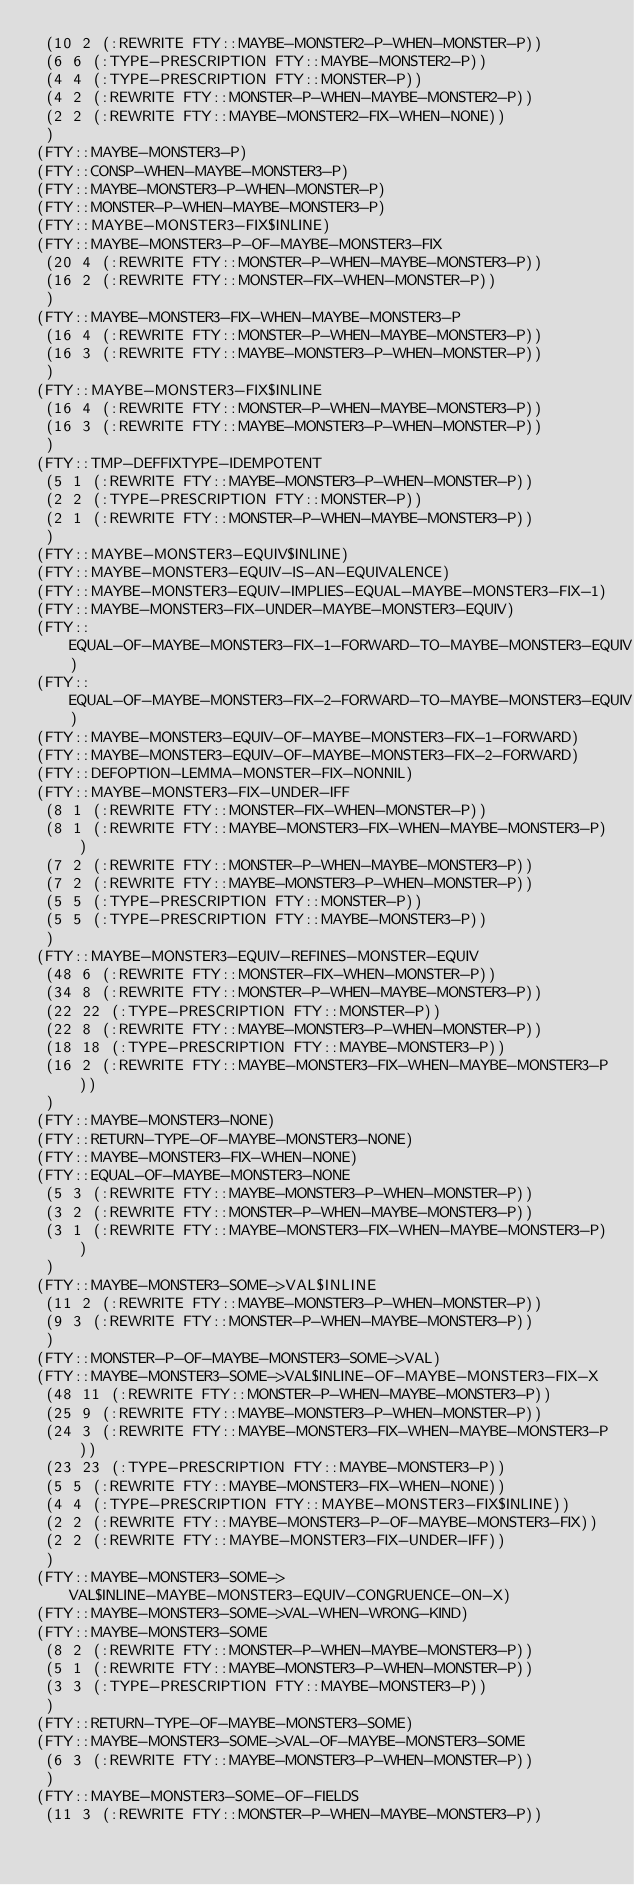<code> <loc_0><loc_0><loc_500><loc_500><_Lisp_> (10 2 (:REWRITE FTY::MAYBE-MONSTER2-P-WHEN-MONSTER-P))
 (6 6 (:TYPE-PRESCRIPTION FTY::MAYBE-MONSTER2-P))
 (4 4 (:TYPE-PRESCRIPTION FTY::MONSTER-P))
 (4 2 (:REWRITE FTY::MONSTER-P-WHEN-MAYBE-MONSTER2-P))
 (2 2 (:REWRITE FTY::MAYBE-MONSTER2-FIX-WHEN-NONE))
 )
(FTY::MAYBE-MONSTER3-P)
(FTY::CONSP-WHEN-MAYBE-MONSTER3-P)
(FTY::MAYBE-MONSTER3-P-WHEN-MONSTER-P)
(FTY::MONSTER-P-WHEN-MAYBE-MONSTER3-P)
(FTY::MAYBE-MONSTER3-FIX$INLINE)
(FTY::MAYBE-MONSTER3-P-OF-MAYBE-MONSTER3-FIX
 (20 4 (:REWRITE FTY::MONSTER-P-WHEN-MAYBE-MONSTER3-P))
 (16 2 (:REWRITE FTY::MONSTER-FIX-WHEN-MONSTER-P))
 )
(FTY::MAYBE-MONSTER3-FIX-WHEN-MAYBE-MONSTER3-P
 (16 4 (:REWRITE FTY::MONSTER-P-WHEN-MAYBE-MONSTER3-P))
 (16 3 (:REWRITE FTY::MAYBE-MONSTER3-P-WHEN-MONSTER-P))
 )
(FTY::MAYBE-MONSTER3-FIX$INLINE
 (16 4 (:REWRITE FTY::MONSTER-P-WHEN-MAYBE-MONSTER3-P))
 (16 3 (:REWRITE FTY::MAYBE-MONSTER3-P-WHEN-MONSTER-P))
 )
(FTY::TMP-DEFFIXTYPE-IDEMPOTENT
 (5 1 (:REWRITE FTY::MAYBE-MONSTER3-P-WHEN-MONSTER-P))
 (2 2 (:TYPE-PRESCRIPTION FTY::MONSTER-P))
 (2 1 (:REWRITE FTY::MONSTER-P-WHEN-MAYBE-MONSTER3-P))
 )
(FTY::MAYBE-MONSTER3-EQUIV$INLINE)
(FTY::MAYBE-MONSTER3-EQUIV-IS-AN-EQUIVALENCE)
(FTY::MAYBE-MONSTER3-EQUIV-IMPLIES-EQUAL-MAYBE-MONSTER3-FIX-1)
(FTY::MAYBE-MONSTER3-FIX-UNDER-MAYBE-MONSTER3-EQUIV)
(FTY::EQUAL-OF-MAYBE-MONSTER3-FIX-1-FORWARD-TO-MAYBE-MONSTER3-EQUIV)
(FTY::EQUAL-OF-MAYBE-MONSTER3-FIX-2-FORWARD-TO-MAYBE-MONSTER3-EQUIV)
(FTY::MAYBE-MONSTER3-EQUIV-OF-MAYBE-MONSTER3-FIX-1-FORWARD)
(FTY::MAYBE-MONSTER3-EQUIV-OF-MAYBE-MONSTER3-FIX-2-FORWARD)
(FTY::DEFOPTION-LEMMA-MONSTER-FIX-NONNIL)
(FTY::MAYBE-MONSTER3-FIX-UNDER-IFF
 (8 1 (:REWRITE FTY::MONSTER-FIX-WHEN-MONSTER-P))
 (8 1 (:REWRITE FTY::MAYBE-MONSTER3-FIX-WHEN-MAYBE-MONSTER3-P))
 (7 2 (:REWRITE FTY::MONSTER-P-WHEN-MAYBE-MONSTER3-P))
 (7 2 (:REWRITE FTY::MAYBE-MONSTER3-P-WHEN-MONSTER-P))
 (5 5 (:TYPE-PRESCRIPTION FTY::MONSTER-P))
 (5 5 (:TYPE-PRESCRIPTION FTY::MAYBE-MONSTER3-P))
 )
(FTY::MAYBE-MONSTER3-EQUIV-REFINES-MONSTER-EQUIV
 (48 6 (:REWRITE FTY::MONSTER-FIX-WHEN-MONSTER-P))
 (34 8 (:REWRITE FTY::MONSTER-P-WHEN-MAYBE-MONSTER3-P))
 (22 22 (:TYPE-PRESCRIPTION FTY::MONSTER-P))
 (22 8 (:REWRITE FTY::MAYBE-MONSTER3-P-WHEN-MONSTER-P))
 (18 18 (:TYPE-PRESCRIPTION FTY::MAYBE-MONSTER3-P))
 (16 2 (:REWRITE FTY::MAYBE-MONSTER3-FIX-WHEN-MAYBE-MONSTER3-P))
 )
(FTY::MAYBE-MONSTER3-NONE)
(FTY::RETURN-TYPE-OF-MAYBE-MONSTER3-NONE)
(FTY::MAYBE-MONSTER3-FIX-WHEN-NONE)
(FTY::EQUAL-OF-MAYBE-MONSTER3-NONE
 (5 3 (:REWRITE FTY::MAYBE-MONSTER3-P-WHEN-MONSTER-P))
 (3 2 (:REWRITE FTY::MONSTER-P-WHEN-MAYBE-MONSTER3-P))
 (3 1 (:REWRITE FTY::MAYBE-MONSTER3-FIX-WHEN-MAYBE-MONSTER3-P))
 )
(FTY::MAYBE-MONSTER3-SOME->VAL$INLINE
 (11 2 (:REWRITE FTY::MAYBE-MONSTER3-P-WHEN-MONSTER-P))
 (9 3 (:REWRITE FTY::MONSTER-P-WHEN-MAYBE-MONSTER3-P))
 )
(FTY::MONSTER-P-OF-MAYBE-MONSTER3-SOME->VAL)
(FTY::MAYBE-MONSTER3-SOME->VAL$INLINE-OF-MAYBE-MONSTER3-FIX-X
 (48 11 (:REWRITE FTY::MONSTER-P-WHEN-MAYBE-MONSTER3-P))
 (25 9 (:REWRITE FTY::MAYBE-MONSTER3-P-WHEN-MONSTER-P))
 (24 3 (:REWRITE FTY::MAYBE-MONSTER3-FIX-WHEN-MAYBE-MONSTER3-P))
 (23 23 (:TYPE-PRESCRIPTION FTY::MAYBE-MONSTER3-P))
 (5 5 (:REWRITE FTY::MAYBE-MONSTER3-FIX-WHEN-NONE))
 (4 4 (:TYPE-PRESCRIPTION FTY::MAYBE-MONSTER3-FIX$INLINE))
 (2 2 (:REWRITE FTY::MAYBE-MONSTER3-P-OF-MAYBE-MONSTER3-FIX))
 (2 2 (:REWRITE FTY::MAYBE-MONSTER3-FIX-UNDER-IFF))
 )
(FTY::MAYBE-MONSTER3-SOME->VAL$INLINE-MAYBE-MONSTER3-EQUIV-CONGRUENCE-ON-X)
(FTY::MAYBE-MONSTER3-SOME->VAL-WHEN-WRONG-KIND)
(FTY::MAYBE-MONSTER3-SOME
 (8 2 (:REWRITE FTY::MONSTER-P-WHEN-MAYBE-MONSTER3-P))
 (5 1 (:REWRITE FTY::MAYBE-MONSTER3-P-WHEN-MONSTER-P))
 (3 3 (:TYPE-PRESCRIPTION FTY::MAYBE-MONSTER3-P))
 )
(FTY::RETURN-TYPE-OF-MAYBE-MONSTER3-SOME)
(FTY::MAYBE-MONSTER3-SOME->VAL-OF-MAYBE-MONSTER3-SOME
 (6 3 (:REWRITE FTY::MAYBE-MONSTER3-P-WHEN-MONSTER-P))
 )
(FTY::MAYBE-MONSTER3-SOME-OF-FIELDS
 (11 3 (:REWRITE FTY::MONSTER-P-WHEN-MAYBE-MONSTER3-P))</code> 